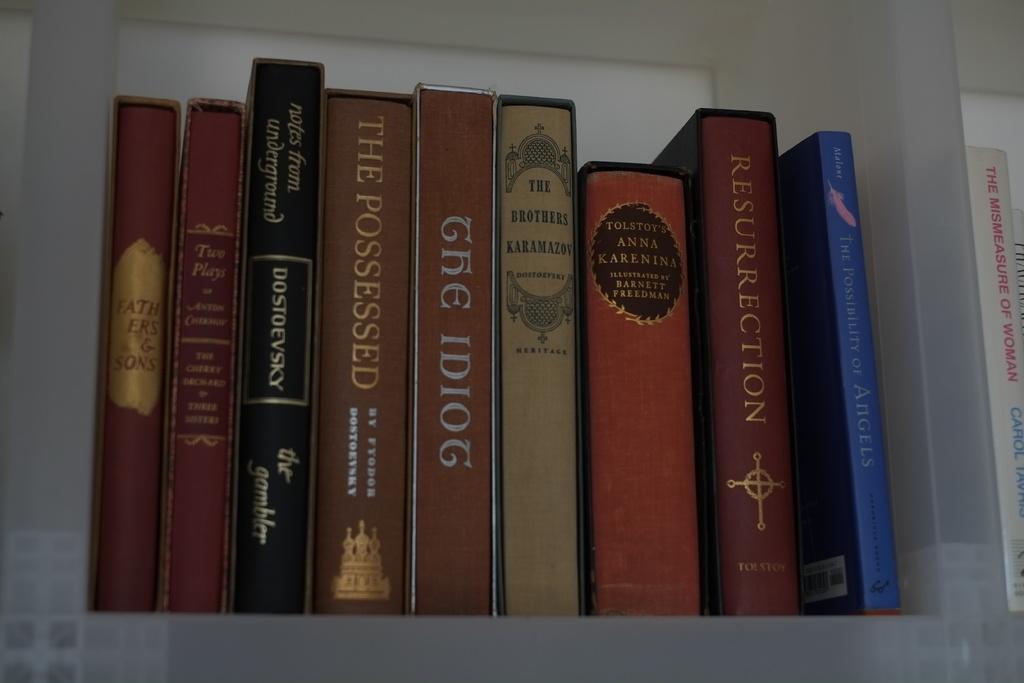Could you give a brief overview of what you see in this image? In this image I can see the books in the rack. These books are colorful. I can see something is written on each book. 